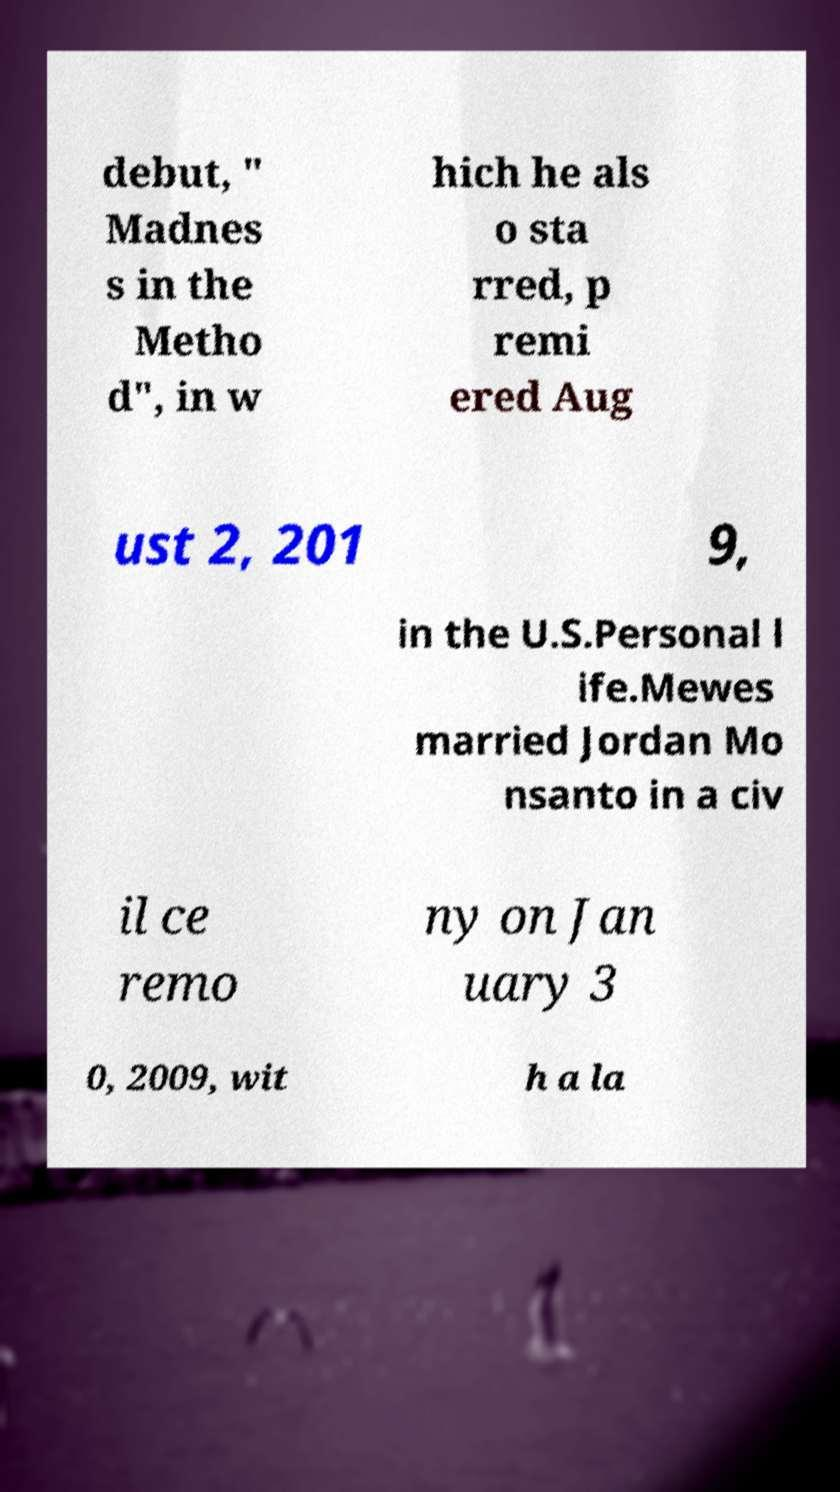Please identify and transcribe the text found in this image. debut, " Madnes s in the Metho d", in w hich he als o sta rred, p remi ered Aug ust 2, 201 9, in the U.S.Personal l ife.Mewes married Jordan Mo nsanto in a civ il ce remo ny on Jan uary 3 0, 2009, wit h a la 